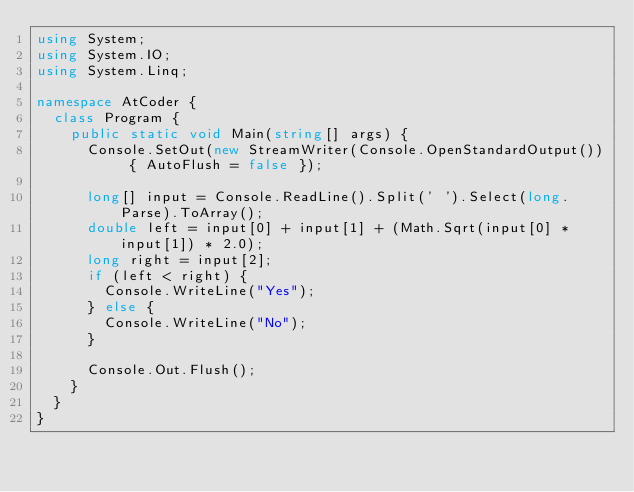Convert code to text. <code><loc_0><loc_0><loc_500><loc_500><_C#_>using System;
using System.IO;
using System.Linq;

namespace AtCoder {
	class Program {
		public static void Main(string[] args) {
			Console.SetOut(new StreamWriter(Console.OpenStandardOutput()) { AutoFlush = false });

			long[] input = Console.ReadLine().Split(' ').Select(long.Parse).ToArray();
			double left = input[0] + input[1] + (Math.Sqrt(input[0] * input[1]) * 2.0);
			long right = input[2];
			if (left < right) {
				Console.WriteLine("Yes");
			} else {
				Console.WriteLine("No");
			}

			Console.Out.Flush();
		}
	}
}
</code> 